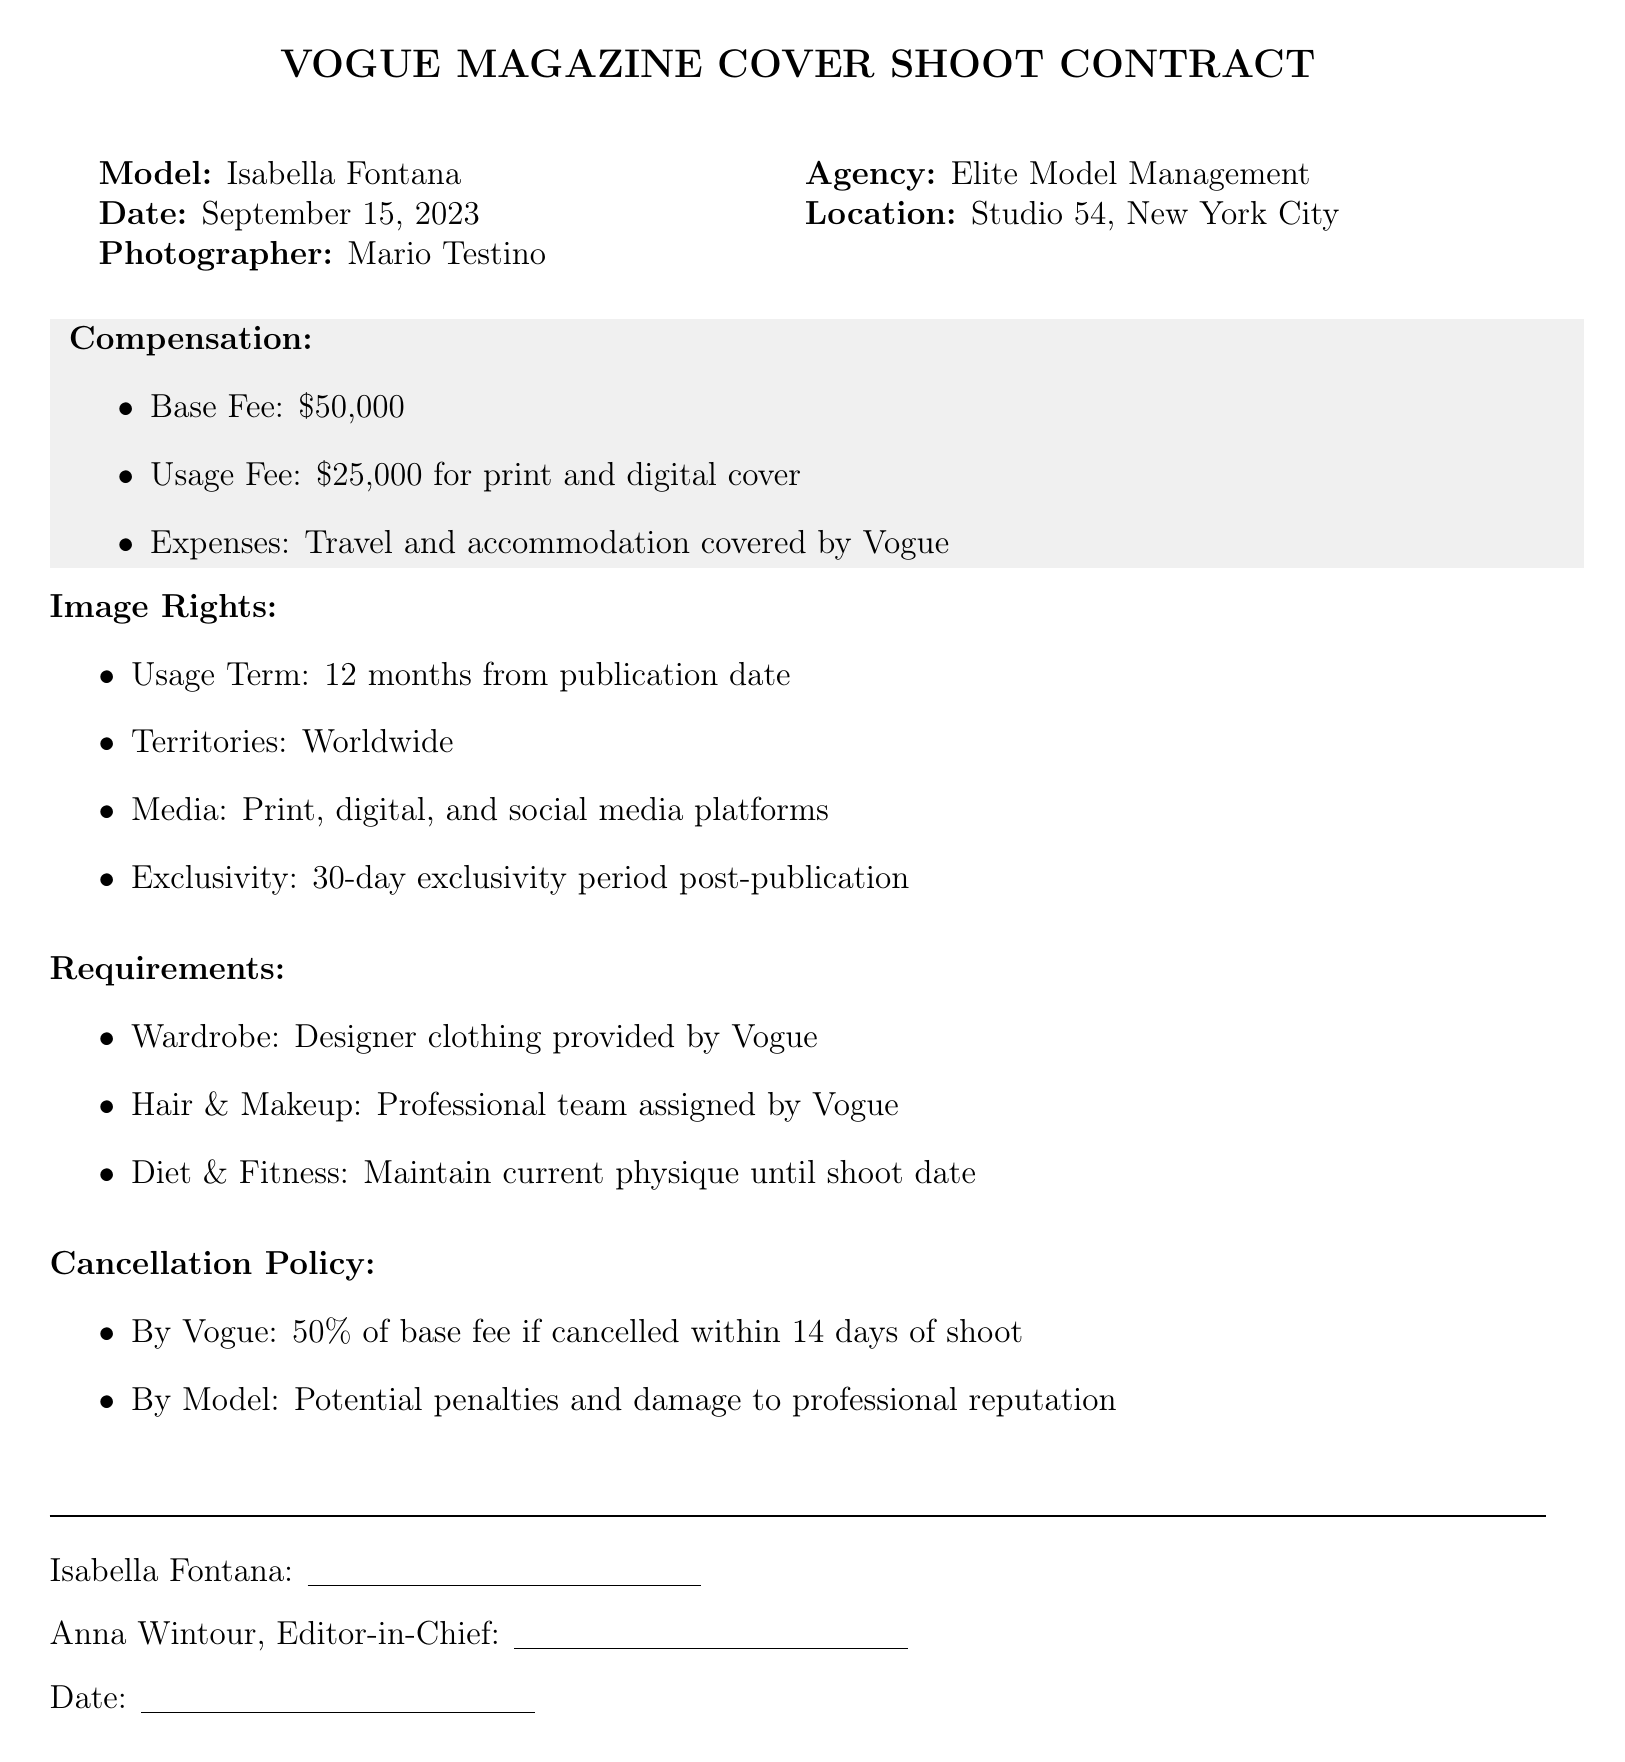What is the model's name? The model's name is indicated at the top of the document, specifically in the introduction section.
Answer: Isabella Fontana What is the base fee for the shoot? The base fee is explicitly listed under the Compensation section of the document.
Answer: $50,000 Who is the photographer for the shoot? The photographer's name is mentioned alongside the model and agency in the introduction section.
Answer: Mario Testino What is the duration of the usage term for image rights? The usage term is specified clearly under the Image Rights section.
Answer: 12 months What percentage of the base fee does Vogue pay if they cancel within 14 days? This percentage is mentioned in the Cancellation Policy section of the document.
Answer: 50% What is included in the wardrobe for the shoot? The document lists the wardrobe requirements under the Requirements section.
Answer: Designer clothing provided by Vogue What is the exclusivity period after publication? The exclusivity period is detailed in the Image Rights section, indicating how long the model's image is not allowed to be used by others.
Answer: 30-day exclusivity What is one requirement pertaining to the model's physical condition? This requirement is detailed in the Requirements section, focusing on the model's fitness.
Answer: Maintain current physique until shoot date 